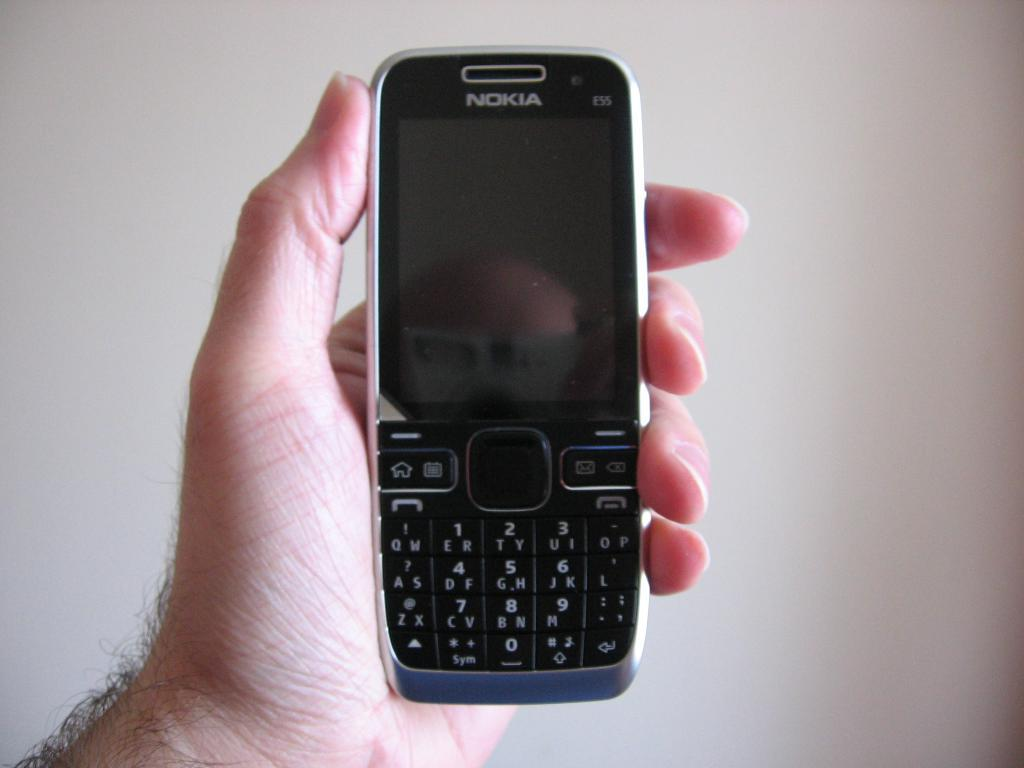<image>
Describe the image concisely. A person holding a black phone made by Nokia. 